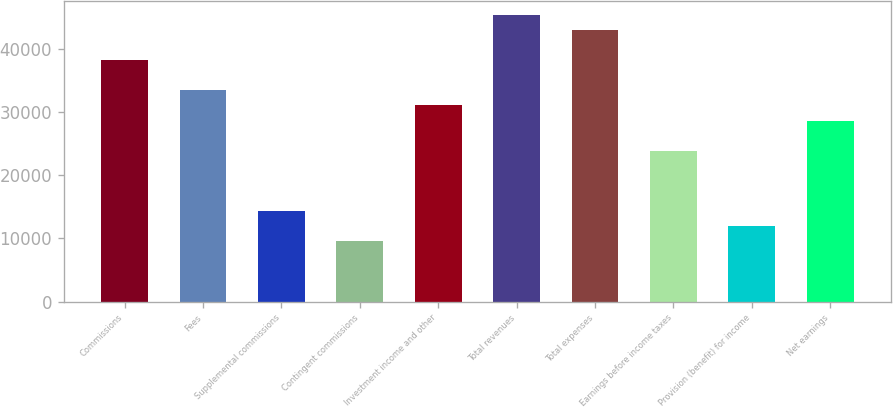<chart> <loc_0><loc_0><loc_500><loc_500><bar_chart><fcel>Commissions<fcel>Fees<fcel>Supplemental commissions<fcel>Contingent commissions<fcel>Investment income and other<fcel>Total revenues<fcel>Total expenses<fcel>Earnings before income taxes<fcel>Provision (benefit) for income<fcel>Net earnings<nl><fcel>38170.3<fcel>33399.2<fcel>14314.8<fcel>9543.68<fcel>31013.6<fcel>45326.9<fcel>42941.4<fcel>23857<fcel>11929.2<fcel>28628.1<nl></chart> 